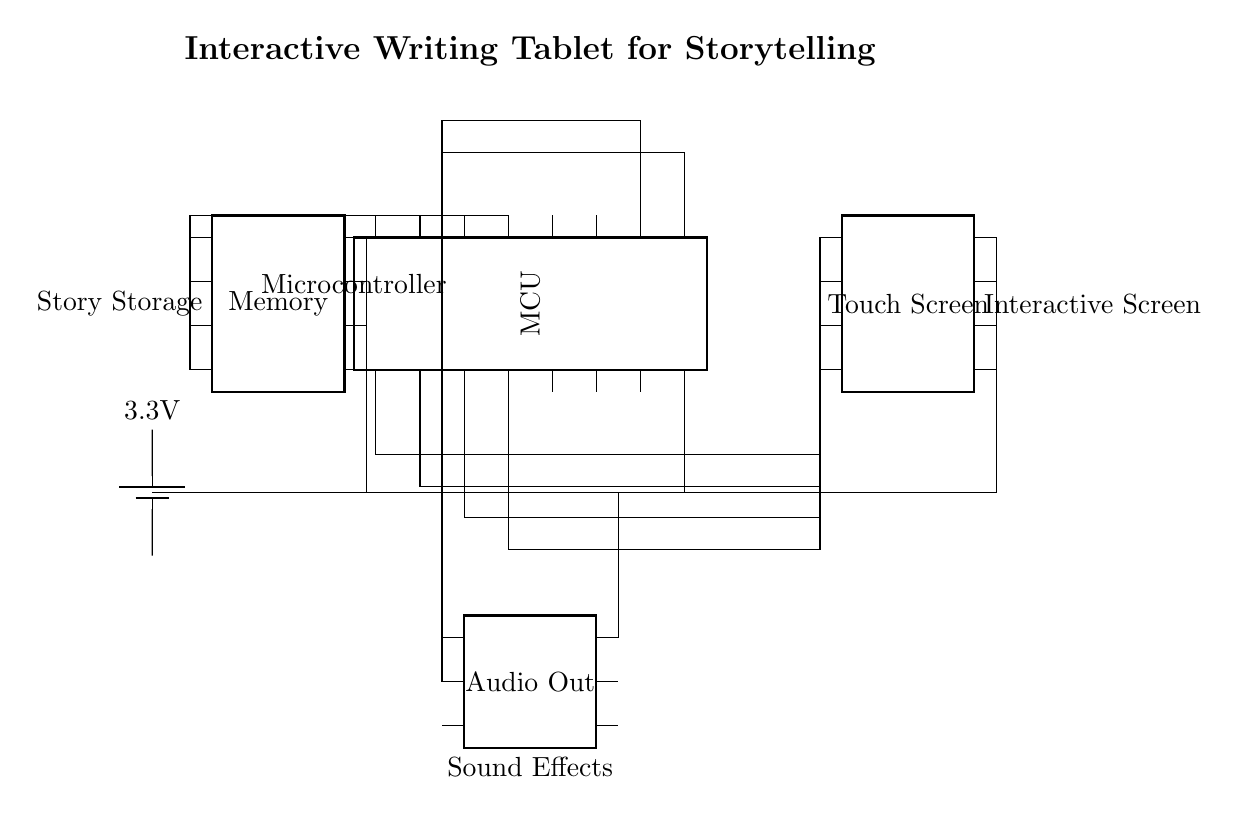What is the main component of the circuit? The main component, represented by the rectangular shape in the circuit, is the microcontroller, which handles the processing.
Answer: Microcontroller How many pins does the touch screen have? The touch screen is depicted having eight pins, as indicated by the number of pin markers around it in the circuit.
Answer: Eight What is the voltage provided by the power supply? The power supply is connected to the circuit and labeled as providing 3.3 volts. This is the potential difference supplied to the components.
Answer: 3.3 volts Which component stores stories? The component labeled as memory is responsible for storing the stories; this can be inferred from the label indicating "Story Storage."
Answer: Memory How many connections does the microcontroller have to the audio output? There are two connections from the microcontroller to the audio output component as shown by the lines connecting their respective pins.
Answer: Two What is the purpose of the audio output component? The audio output component is labeled as producing "Sound Effects," indicating that its role is to generate audio signals for playback.
Answer: Sound Effects Which component directly interacts with the user for input? The touch screen is the component that directly interacts with the user, allowing for input through touch. This is indicated by its placement and label.
Answer: Touch Screen 